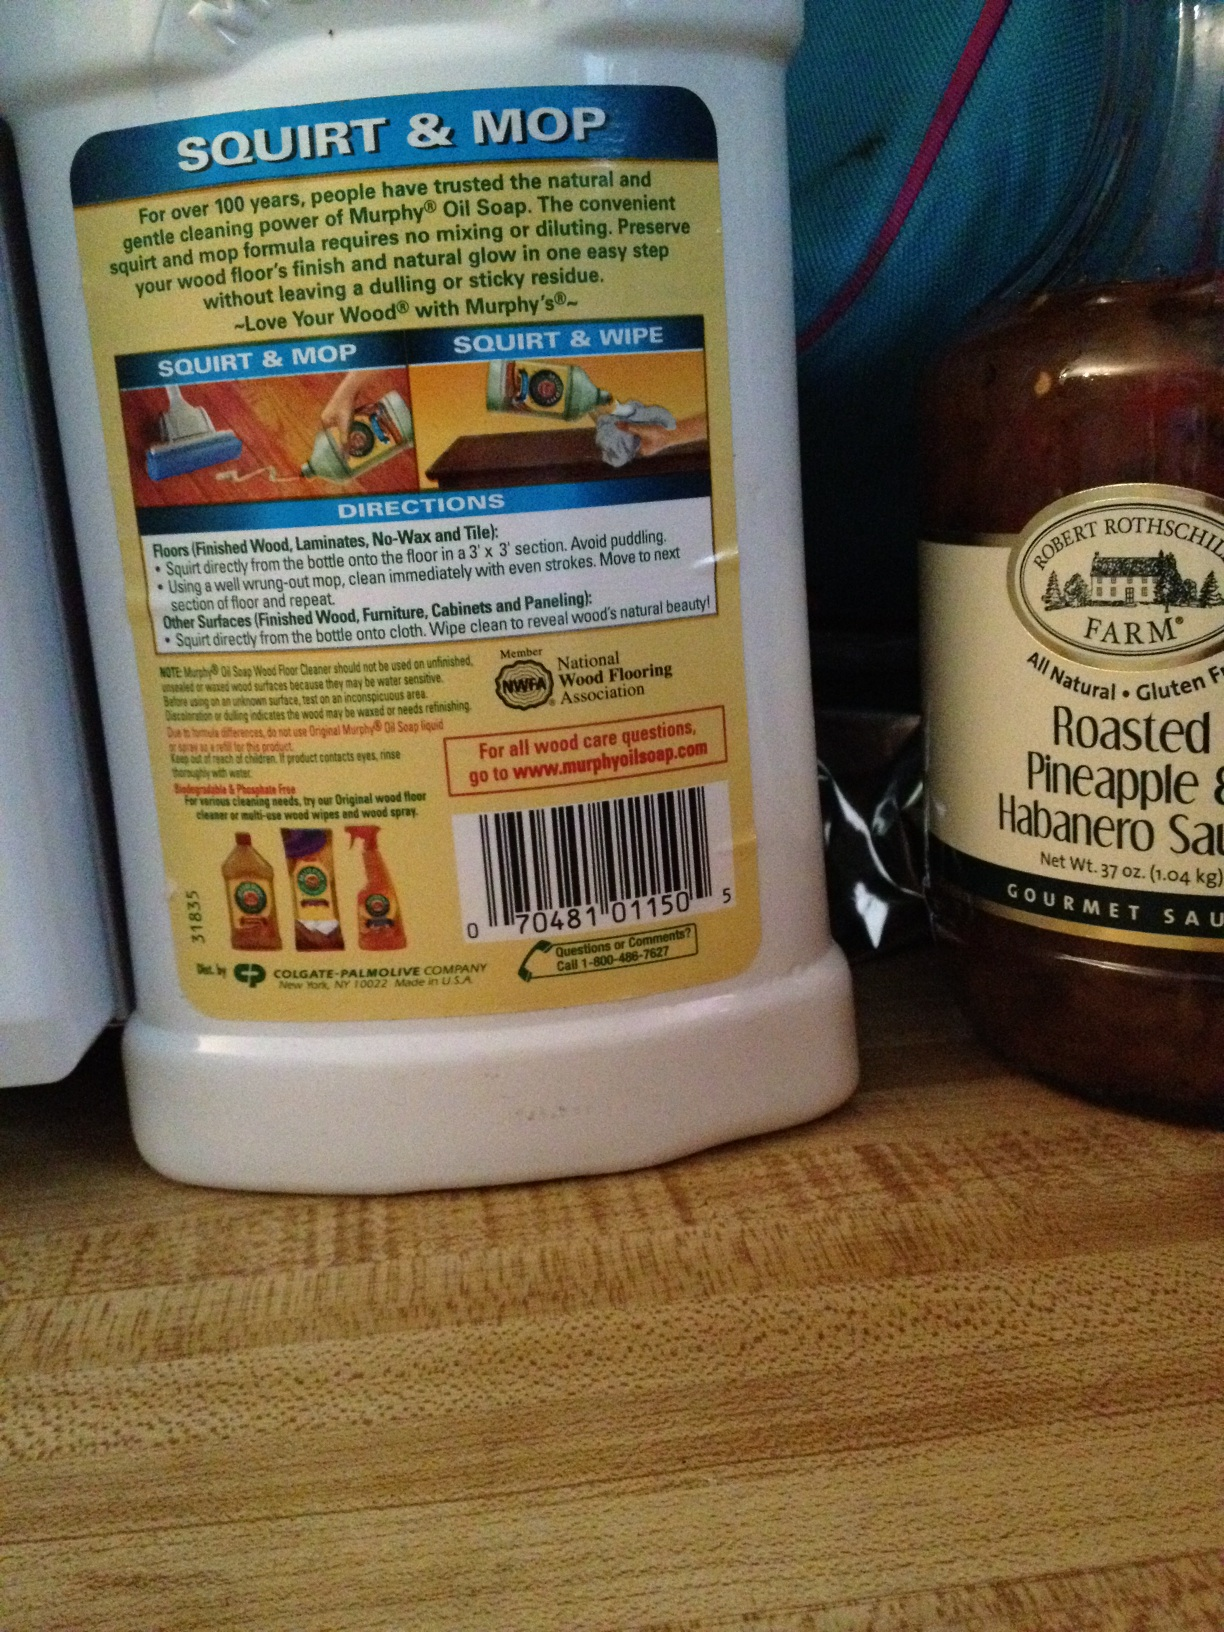What is the name of the product in the bottle in the picture? The product in the bottle is called Murphy’s Oil Soap, which is popular for its natural cleaning properties used particularly on wood surfaces. 